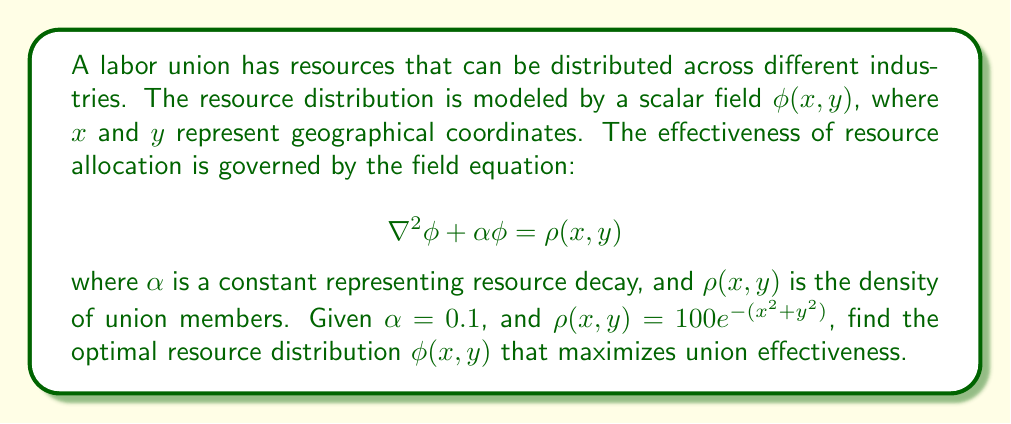Teach me how to tackle this problem. To solve this problem, we need to follow these steps:

1) The given field equation is a modified Helmholtz equation. For radially symmetric problems, it's often useful to transform to polar coordinates $(r, \theta)$.

2) In polar coordinates, the Laplacian operator becomes:

   $$\nabla^2\phi = \frac{1}{r}\frac{\partial}{\partial r}\left(r\frac{\partial \phi}{\partial r}\right) + \frac{1}{r^2}\frac{\partial^2 \phi}{\partial \theta^2}$$

3) Given the radial symmetry of $\rho(x, y)$, we can assume $\phi$ is also radially symmetric, so $\frac{\partial^2 \phi}{\partial \theta^2} = 0$.

4) The equation becomes:

   $$\frac{1}{r}\frac{d}{dr}\left(r\frac{d\phi}{dr}\right) + 0.1\phi = 100e^{-r^2}$$

5) To solve this, we can use the method of Green's functions. The Green's function for the modified Helmholtz equation in 2D is:

   $$G(r) = \frac{1}{2\pi}K_0(\sqrt{0.1}r)$$

   where $K_0$ is the modified Bessel function of the second kind.

6) The solution is given by the convolution:

   $$\phi(r) = \int_0^\infty \int_0^{2\pi} G(|r-r'|) \rho(r') r' dr' d\theta'$$

7) Substituting and simplifying:

   $$\phi(r) = 100 \int_0^\infty K_0(\sqrt{0.1}|r-r'|)e^{-r'^2}r'dr'$$

8) This integral doesn't have a closed-form solution, but it can be evaluated numerically to find $\phi(r)$ for any given $r$.
Answer: $\phi(r) = 100 \int_0^\infty K_0(\sqrt{0.1}|r-r'|)e^{-r'^2}r'dr'$ 